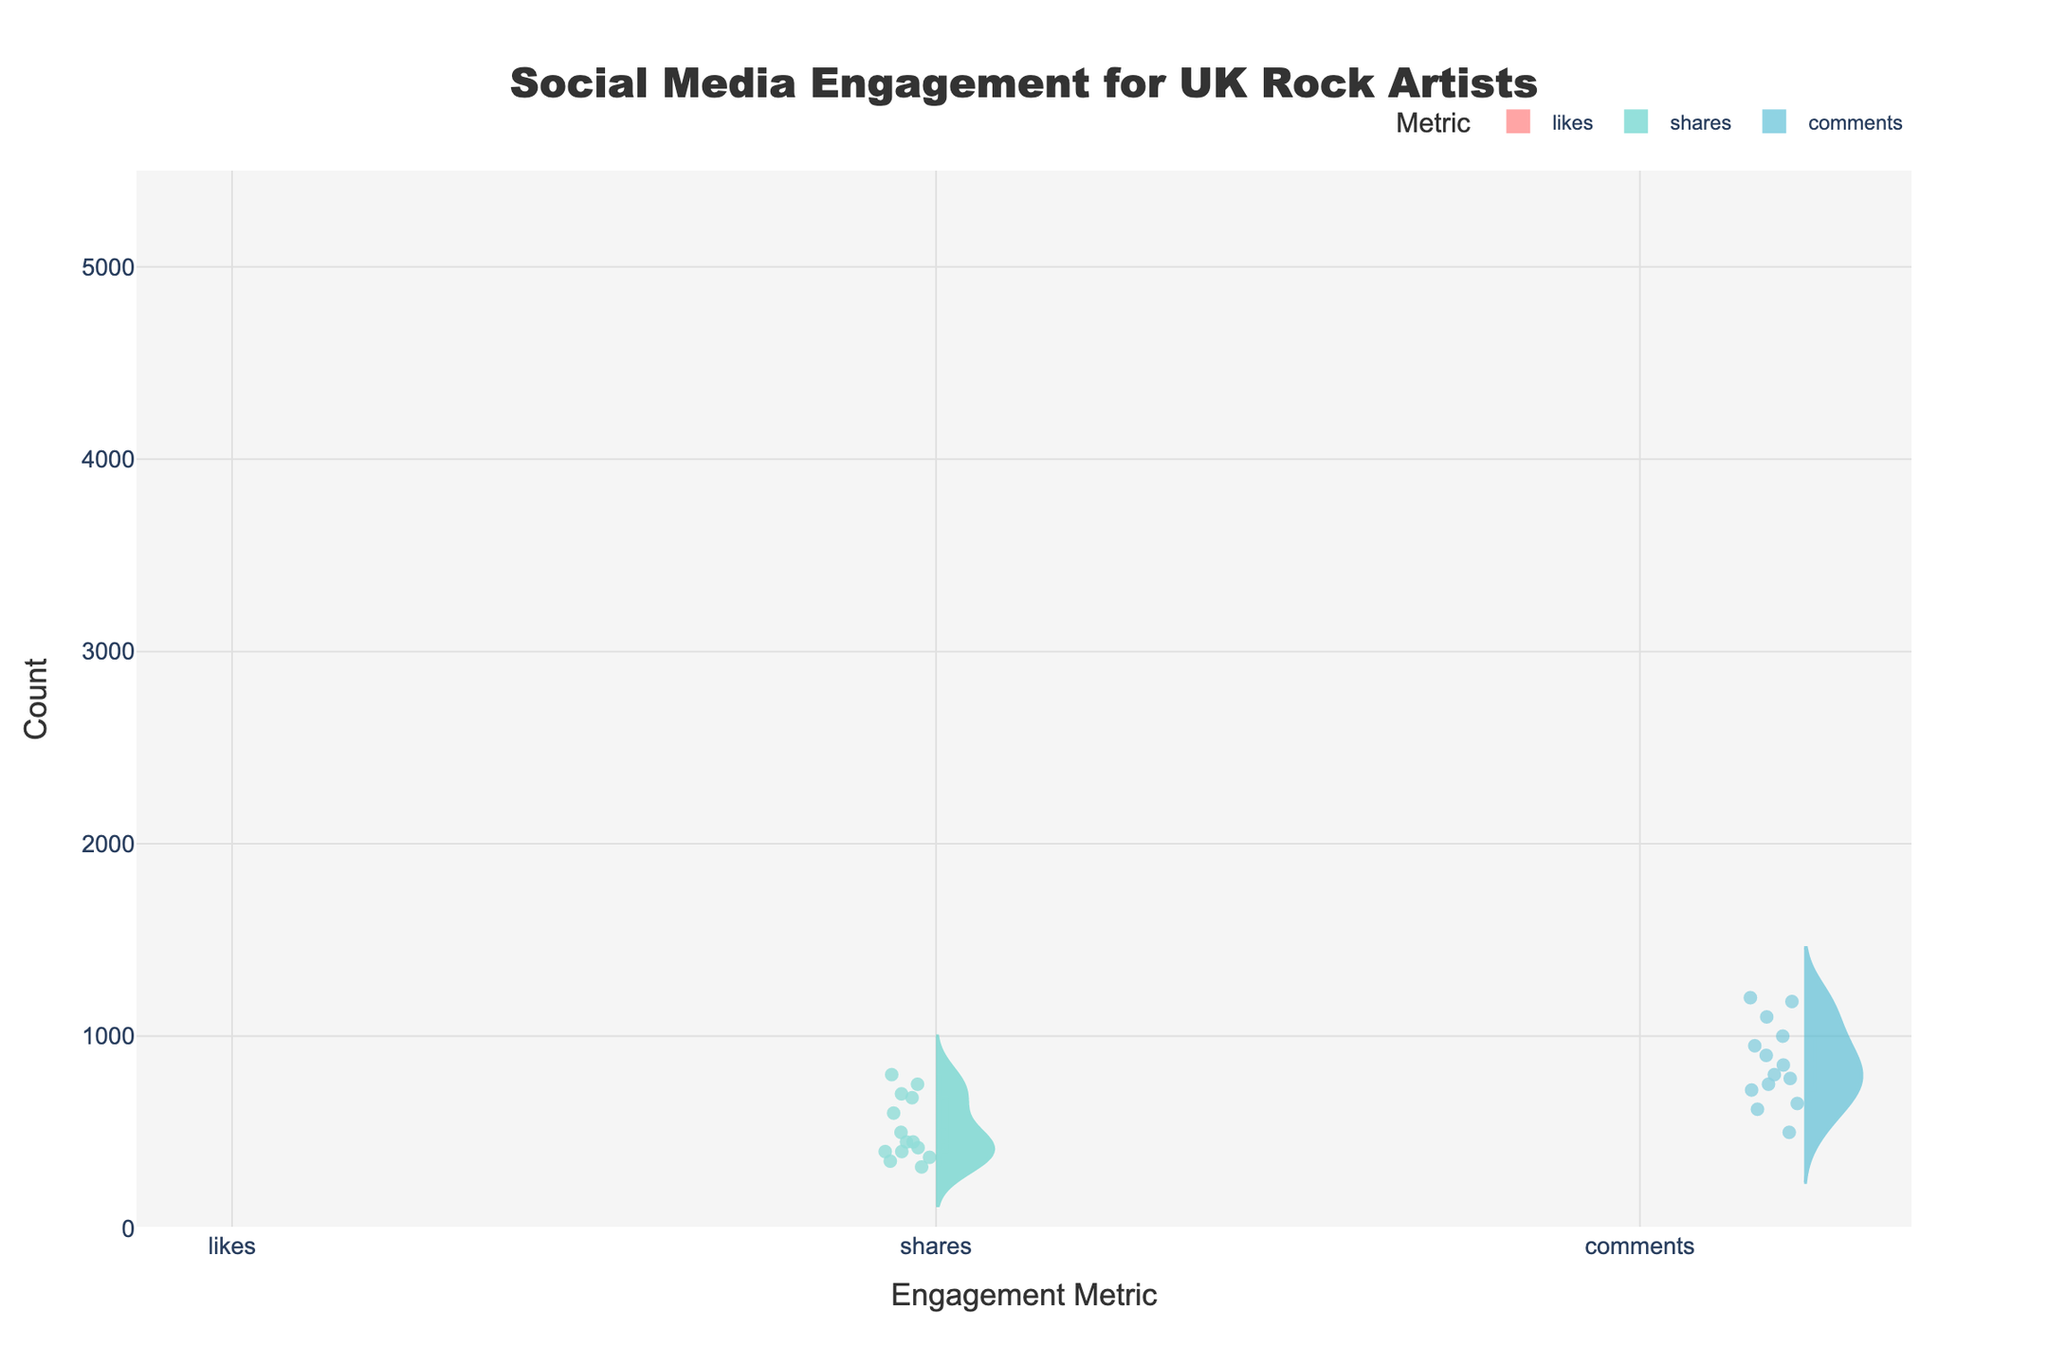what does the title of the figure say? The title of the figure is usually placed at the top of the chart and is meant to give a quick summary of what the chart depicts. In this case, the title reads "Social Media Engagement for UK Rock Artists," indicating the chart displays engagement metrics like likes, shares, and comments for rock artists in the UK.
Answer: Social Media Engagement for UK Rock Artists How many different engagement metrics are displayed in the chart? The chart displays three different engagement metrics. These metrics are 'likes,' 'shares,' and 'comments' as indicated by the separate violin plots with distinct labels.
Answer: Three Which engagement metric has the highest mean value? Violin plots with visible mean lines allow for quick comparison of average values. By visually inspecting which mean line is the highest, we can identify that 'likes' have the highest mean value among the three engagement metrics in the figure.
Answer: Likes Do 'likes' generally have a wider range of values compared to 'shares' and 'comments'? The width of the violin plot represents the distribution range and density of the data. The 'likes' violin plot is wider than those for 'shares' and 'comments,' indicating that likes generally have a wider range of values.
Answer: Yes What is the average amount of likes and comments for Arctic Monkeys? To find the average, sum the amount of likes and comments for Arctic Monkeys and divide by 2. Likes: 4500, Comments: 1180. Sum = 4500 + 1180 = 5680, Average = 5680 / 2 = 2840.
Answer: 2840 Which artist has the highest count of likes? Hovering over or visually checking the point with the highest value within the 'likes' violin plot will show the artist. Radiohead, with 5000 likes, appears at the top.
Answer: Radiohead Is the variability in 'shares' generally higher or lower than 'likes'? The vertical spread of a violin plot can be used to assess variability. The 'shares' plot has a more compact vertical spread compared to the 'likes' plot, indicating that shares have lower variability.
Answer: Lower Between 'Royal Blood' and 'Bastille', who has more comments? By comparing the individual data points in the 'comments' section of the figure, you can see that Royal Blood has 650 comments while Bastille has 750 comments.
Answer: Bastille How does the median number of comments compare between 'likes' and 'shares'? The median is usually indicated by a line within the box in each violin plot. By comparing the median lines, we can see that the median number of comments falls in between the medians for likes and shares.
Answer: In between 